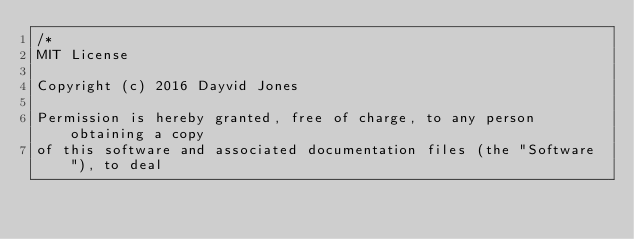<code> <loc_0><loc_0><loc_500><loc_500><_C#_>/*
MIT License

Copyright (c) 2016 Dayvid Jones

Permission is hereby granted, free of charge, to any person obtaining a copy
of this software and associated documentation files (the "Software"), to deal</code> 